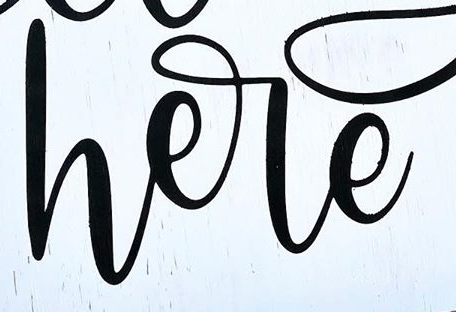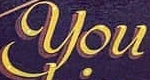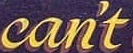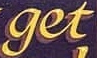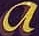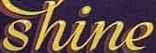Read the text content from these images in order, separated by a semicolon. here; You; can't; get; a; shine 